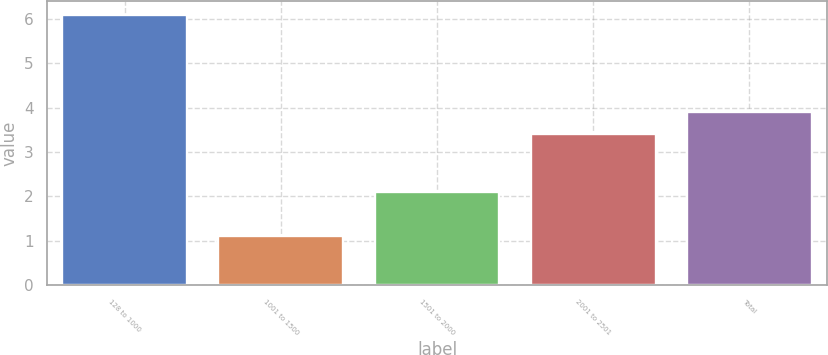<chart> <loc_0><loc_0><loc_500><loc_500><bar_chart><fcel>128 to 1000<fcel>1001 to 1500<fcel>1501 to 2000<fcel>2001 to 2501<fcel>Total<nl><fcel>6.1<fcel>1.1<fcel>2.1<fcel>3.4<fcel>3.9<nl></chart> 